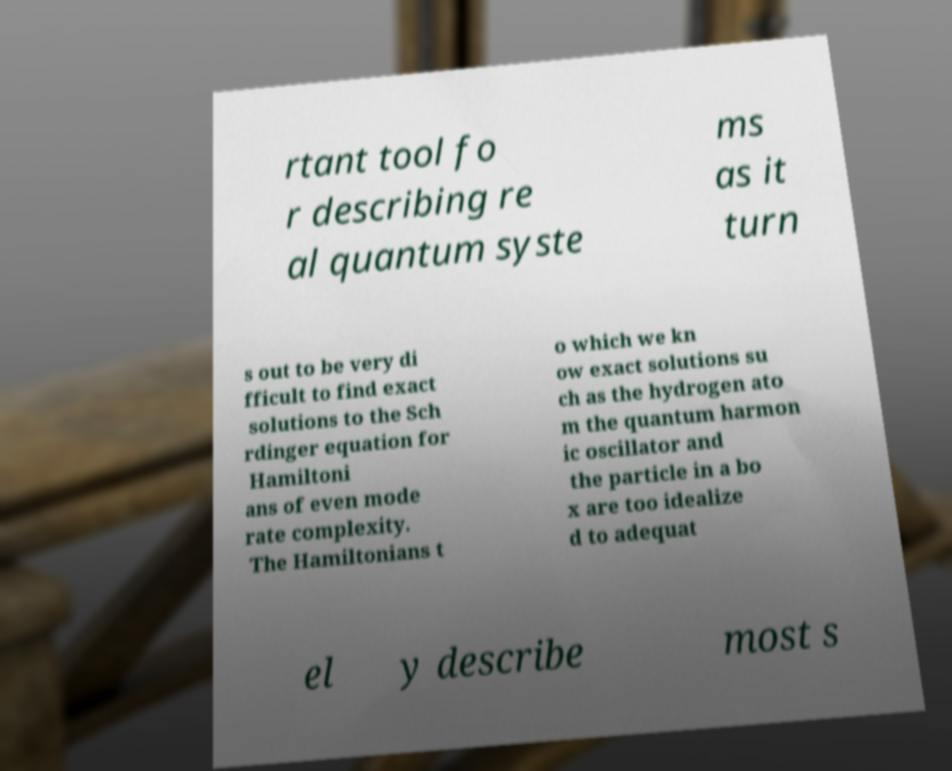Could you assist in decoding the text presented in this image and type it out clearly? rtant tool fo r describing re al quantum syste ms as it turn s out to be very di fficult to find exact solutions to the Sch rdinger equation for Hamiltoni ans of even mode rate complexity. The Hamiltonians t o which we kn ow exact solutions su ch as the hydrogen ato m the quantum harmon ic oscillator and the particle in a bo x are too idealize d to adequat el y describe most s 